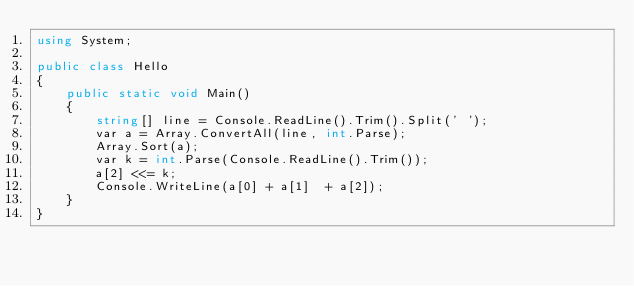<code> <loc_0><loc_0><loc_500><loc_500><_C#_>using System;

public class Hello
{
    public static void Main()
    {
        string[] line = Console.ReadLine().Trim().Split(' ');
        var a = Array.ConvertAll(line, int.Parse);
        Array.Sort(a);
        var k = int.Parse(Console.ReadLine().Trim());
        a[2] <<= k;
        Console.WriteLine(a[0] + a[1]  + a[2]);
    }
}</code> 